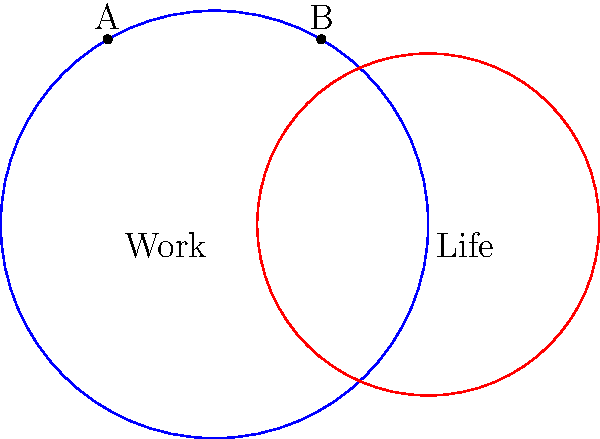In the journey towards work-life harmony, two circles represent the realms of work and life. The work circle has a radius of 1 unit, while the life circle has a radius of 0.8 units. The centers of these circles are 1 unit apart. What is the area of the overlapping region, symbolizing the perfect balance between work and life? To find the area of overlap between two circles, we can follow these steps:

1. Identify the radii: $r_1 = 1$ (work) and $r_2 = 0.8$ (life)
2. Distance between centers: $d = 1$

3. Calculate the central angles using the cosine law:
   $$\cos(\theta_1) = \frac{r_1^2 + d^2 - r_2^2}{2r_1d} = \frac{1^2 + 1^2 - 0.8^2}{2(1)(1)} = 0.68$$
   $$\theta_1 = \arccos(0.68) = 0.8211 \text{ radians}$$
   
   $$\cos(\theta_2) = \frac{r_2^2 + d^2 - r_1^2}{2r_2d} = \frac{0.8^2 + 1^2 - 1^2}{2(0.8)(1)} = 0.5$$
   $$\theta_2 = \arccos(0.5) = 1.0472 \text{ radians}$$

4. Calculate the areas of the circular sectors:
   $$A_1 = \frac{1}{2}r_1^2\theta_1 = \frac{1}{2}(1^2)(0.8211) = 0.4106$$
   $$A_2 = \frac{1}{2}r_2^2\theta_2 = \frac{1}{2}(0.8^2)(1.0472) = 0.3351$$

5. Calculate the area of the triangle:
   $$A_t = \frac{1}{2}r_1\sin(\theta_1)d = \frac{1}{2}(1)\sin(0.8211)(1) = 0.3660$$

6. The overlapping area is the sum of the sectors minus twice the triangle area:
   $$A_{overlap} = A_1 + A_2 - 2A_t = 0.4106 + 0.3351 - 2(0.3660) = 0.0137$$

Thus, the area of overlap is approximately 0.0137 square units.
Answer: 0.0137 square units 